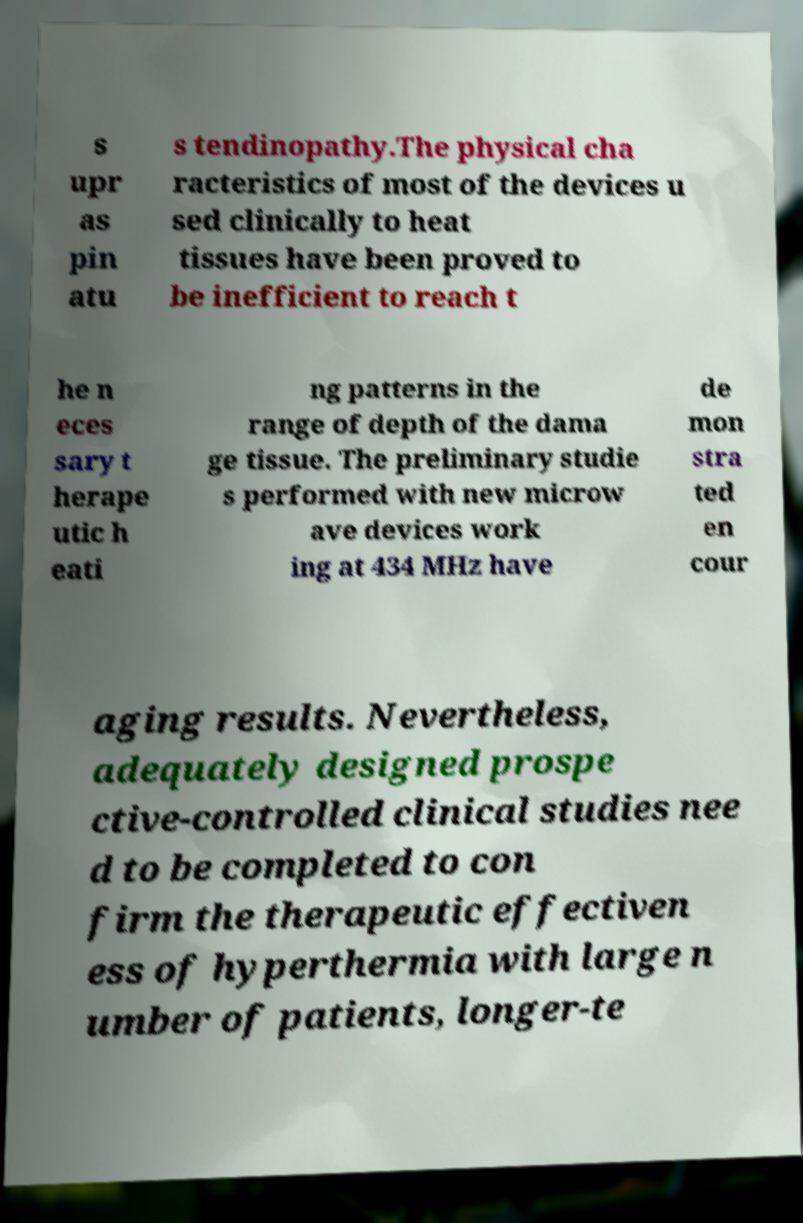Can you accurately transcribe the text from the provided image for me? s upr as pin atu s tendinopathy.The physical cha racteristics of most of the devices u sed clinically to heat tissues have been proved to be inefficient to reach t he n eces sary t herape utic h eati ng patterns in the range of depth of the dama ge tissue. The preliminary studie s performed with new microw ave devices work ing at 434 MHz have de mon stra ted en cour aging results. Nevertheless, adequately designed prospe ctive-controlled clinical studies nee d to be completed to con firm the therapeutic effectiven ess of hyperthermia with large n umber of patients, longer-te 